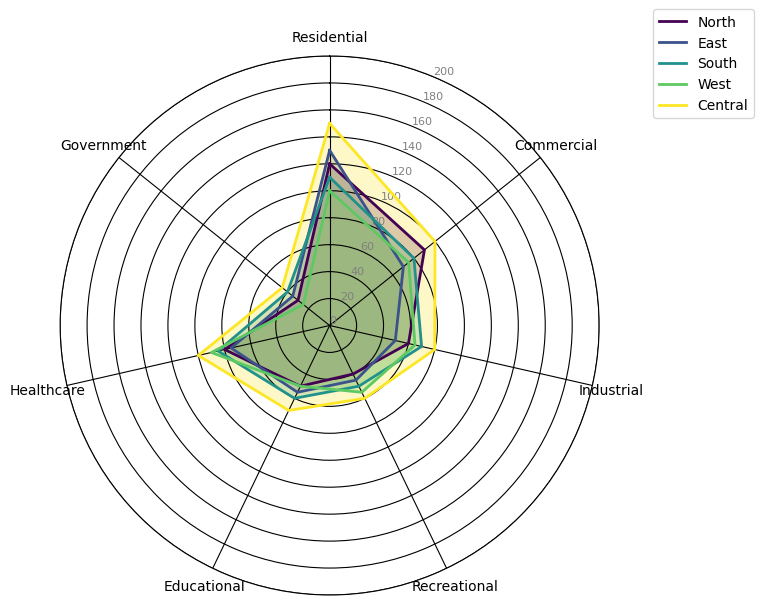Which city zone deploys the most IoT devices in the Residential category? Count the number of IoT devices deployed in the Residential category for each city zone and compare them. North: 120, East: 130, South: 110, West: 100, Central: 150. The highest value is 150 in Central.
Answer: Central Which city zone has the smallest number of IoT devices in the Government category? Count the number of IoT devices deployed in the Government category for each city zone and compare them. North: 30, East: 35, South: 40, West: 25, Central: 45. The smallest value is 25 in West.
Answer: West What is the total number of IoT devices deployed in the Central zone? Sum the number of IoT devices deployed in all categories for the Central zone: 150 (Residential) + 100 (Commercial) + 80 (Industrial) + 60 (Recreational) + 70 (Educational) + 100 (Healthcare) + 45 (Government). Total = 605.
Answer: 605 Which two zones have the closest number of IoT devices deployed in the Healthcare category? Count and compare the IoT devices deployed in the Healthcare category: North: 80, East: 75, South: 85, West: 90, Central: 100. The closest numbers are North (80) and East (75), with a difference of 5.
Answer: North and East Rank the zones based on the number of IoT devices in the Educational category from highest to lowest. Count the IoT devices in the Educational category and rank them: North: 50, East: 55, South: 60, West: 50, Central: 70. Ranking from highest to lowest: Central (70), South (60), East (55), North (50), West (50).
Answer: Central, South, East, North, West 